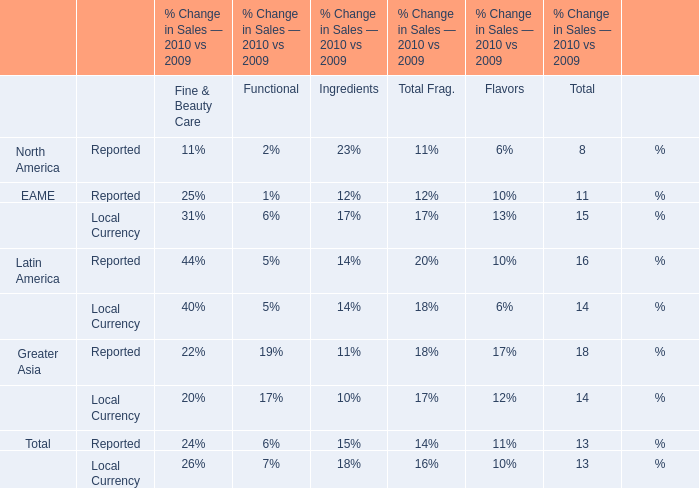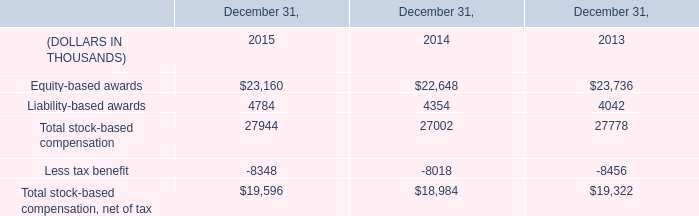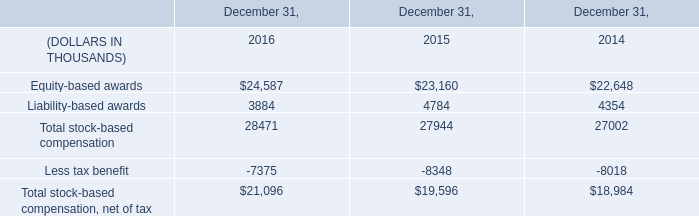In what year is Total Sales Reported for Fine & Beauty Care larger between 2009 and 2010? 
Answer: 2010. 